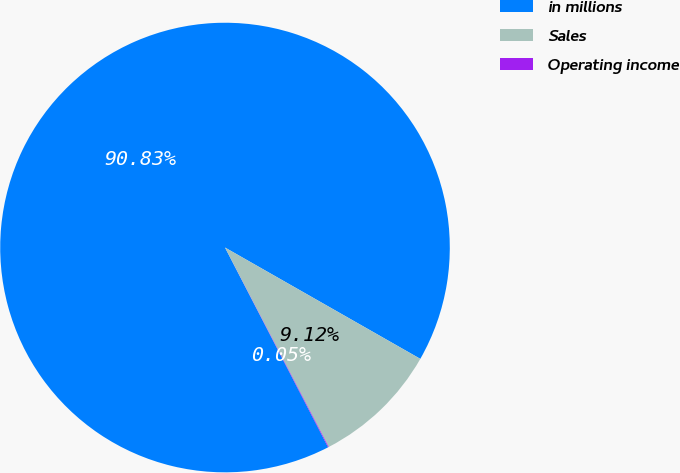Convert chart. <chart><loc_0><loc_0><loc_500><loc_500><pie_chart><fcel>in millions<fcel>Sales<fcel>Operating income<nl><fcel>90.83%<fcel>9.12%<fcel>0.05%<nl></chart> 